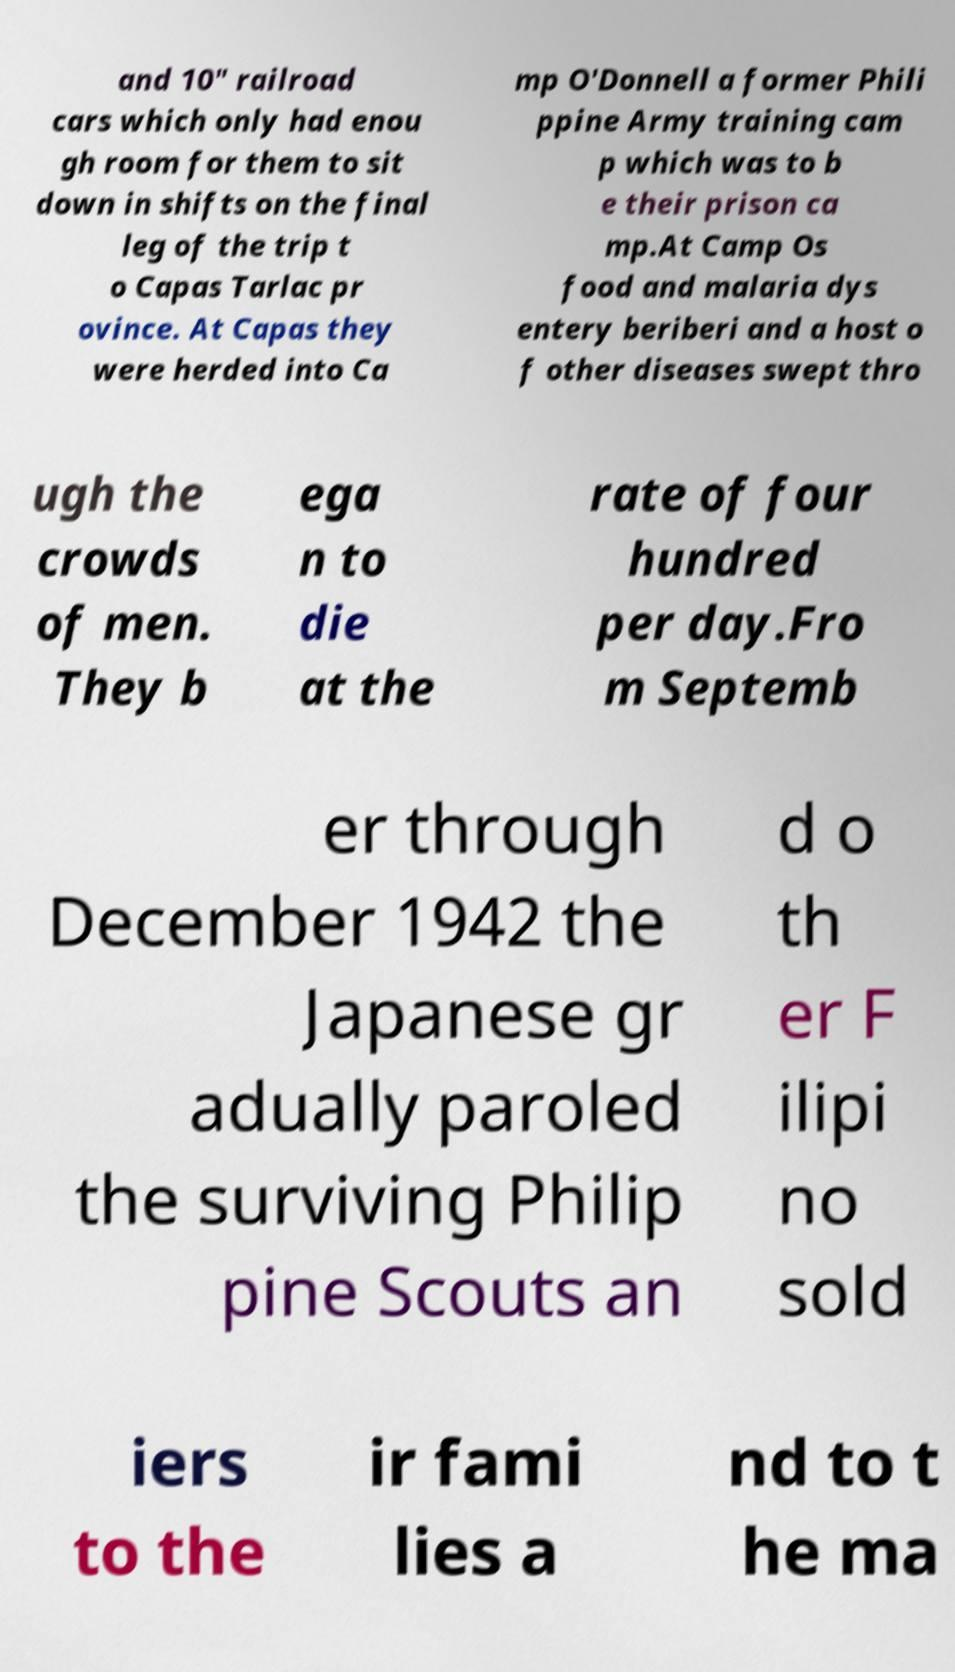Please read and relay the text visible in this image. What does it say? and 10" railroad cars which only had enou gh room for them to sit down in shifts on the final leg of the trip t o Capas Tarlac pr ovince. At Capas they were herded into Ca mp O'Donnell a former Phili ppine Army training cam p which was to b e their prison ca mp.At Camp Os food and malaria dys entery beriberi and a host o f other diseases swept thro ugh the crowds of men. They b ega n to die at the rate of four hundred per day.Fro m Septemb er through December 1942 the Japanese gr adually paroled the surviving Philip pine Scouts an d o th er F ilipi no sold iers to the ir fami lies a nd to t he ma 